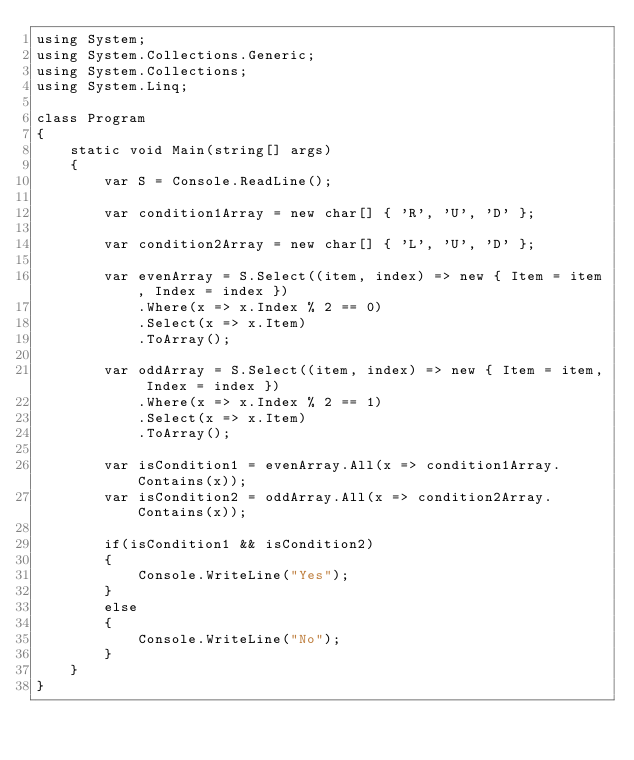Convert code to text. <code><loc_0><loc_0><loc_500><loc_500><_C#_>using System;
using System.Collections.Generic;
using System.Collections;
using System.Linq;

class Program
{
    static void Main(string[] args)
    {
        var S = Console.ReadLine();

        var condition1Array = new char[] { 'R', 'U', 'D' };

        var condition2Array = new char[] { 'L', 'U', 'D' };

        var evenArray = S.Select((item, index) => new { Item = item, Index = index })
            .Where(x => x.Index % 2 == 0)
            .Select(x => x.Item)
            .ToArray();

        var oddArray = S.Select((item, index) => new { Item = item, Index = index })
            .Where(x => x.Index % 2 == 1)
            .Select(x => x.Item)
            .ToArray();

        var isCondition1 = evenArray.All(x => condition1Array.Contains(x));
        var isCondition2 = oddArray.All(x => condition2Array.Contains(x));

        if(isCondition1 && isCondition2)
        {
            Console.WriteLine("Yes");
        }
        else
        {
            Console.WriteLine("No");
        }
    }
}</code> 